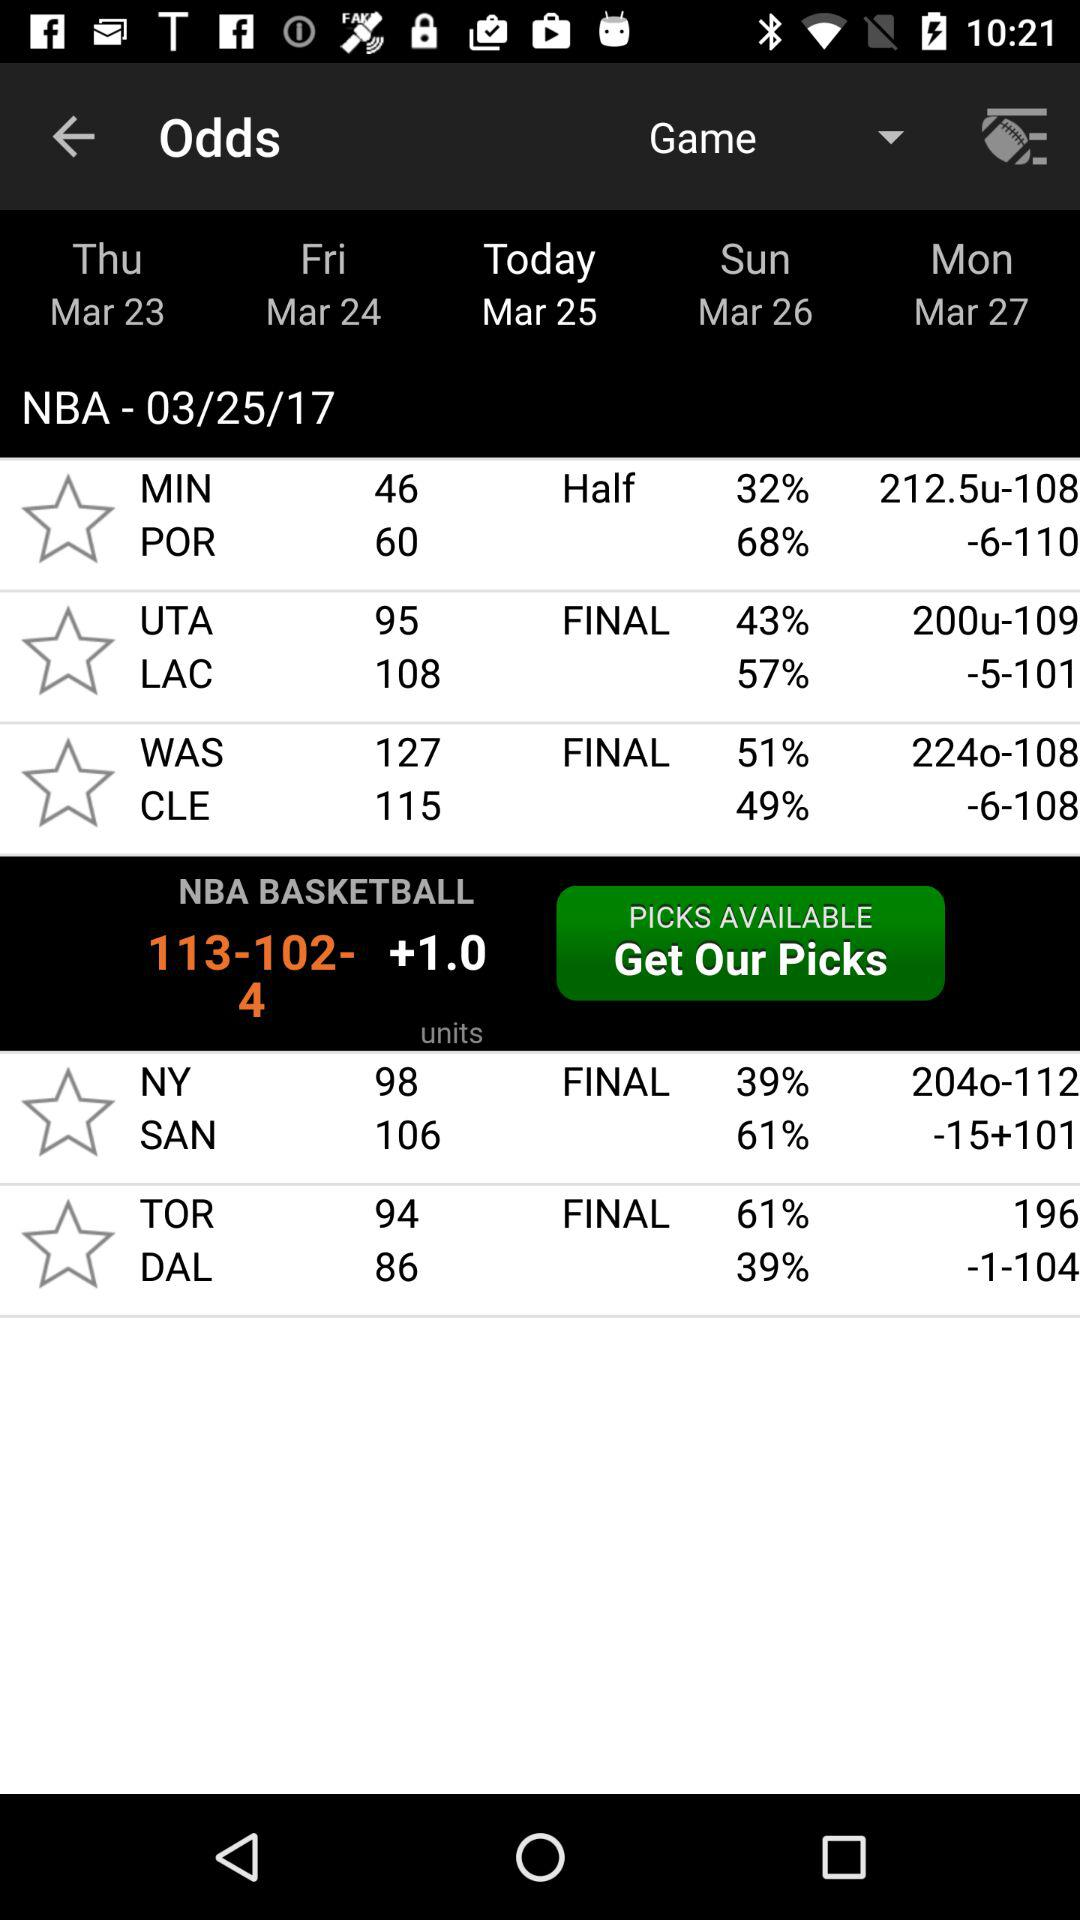Which team has a higher win percentage, MIN or UTA?
Answer the question using a single word or phrase. UTA 